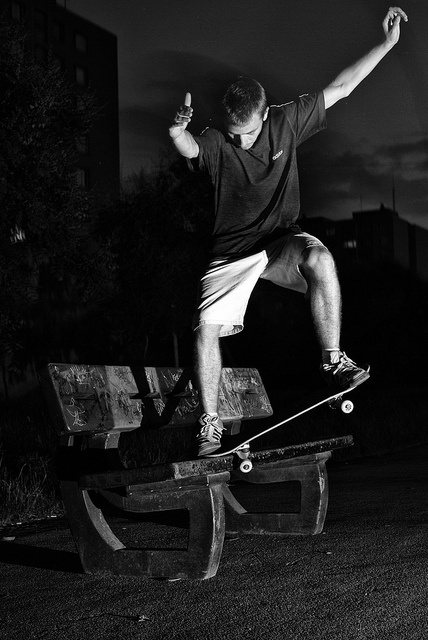Describe the objects in this image and their specific colors. I can see bench in black, gray, darkgray, and lightgray tones, people in black, lightgray, gray, and darkgray tones, and skateboard in black, lightgray, gray, and darkgray tones in this image. 